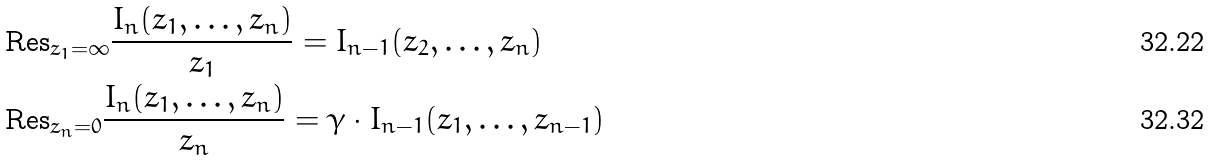<formula> <loc_0><loc_0><loc_500><loc_500>& \text {Res} _ { z _ { 1 } = \infty } \frac { I _ { n } ( z _ { 1 } , \dots , z _ { n } ) } { z _ { 1 } } = I _ { n - 1 } ( z _ { 2 } , \dots , z _ { n } ) \\ & \text {Res} _ { z _ { n } = 0 } \frac { I _ { n } ( z _ { 1 } , \dots , z _ { n } ) } { z _ { n } } = \gamma \cdot I _ { n - 1 } ( z _ { 1 } , \dots , z _ { n - 1 } )</formula> 